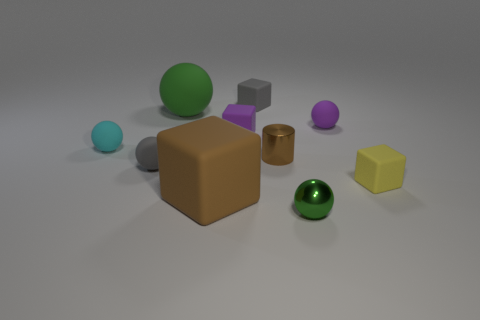Is the number of tiny matte blocks that are behind the tiny cyan object greater than the number of purple spheres that are left of the brown cylinder?
Keep it short and to the point. Yes. Does the tiny green shiny object have the same shape as the tiny metal object that is left of the metal ball?
Your answer should be compact. No. How many other things are there of the same shape as the yellow object?
Your response must be concise. 3. There is a ball that is both behind the small purple block and on the left side of the brown cube; what is its color?
Your response must be concise. Green. The large rubber block is what color?
Your response must be concise. Brown. Is the material of the purple sphere the same as the tiny block that is in front of the tiny purple block?
Offer a terse response. Yes. The green thing that is the same material as the big brown cube is what shape?
Keep it short and to the point. Sphere. There is a cylinder that is the same size as the purple block; what is its color?
Provide a succinct answer. Brown. Is the size of the green object behind the yellow matte object the same as the large block?
Your answer should be compact. Yes. Does the small cylinder have the same color as the big block?
Offer a very short reply. Yes. 